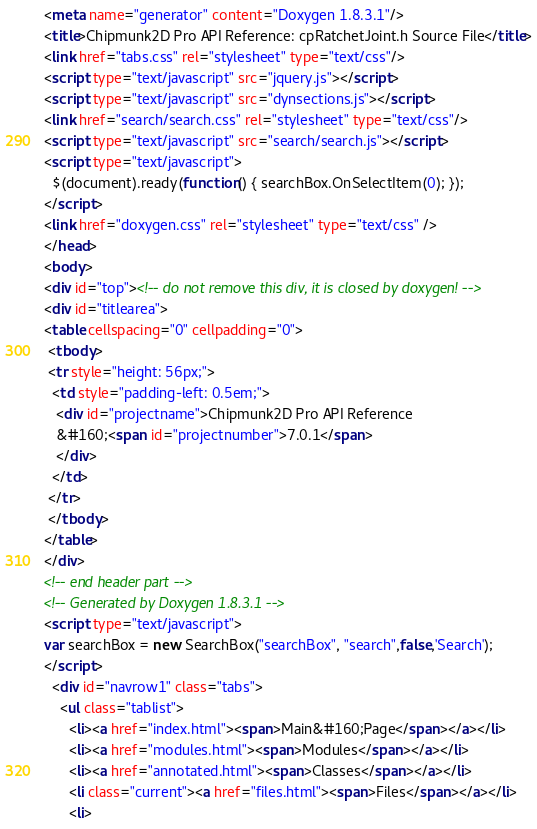<code> <loc_0><loc_0><loc_500><loc_500><_HTML_><meta name="generator" content="Doxygen 1.8.3.1"/>
<title>Chipmunk2D Pro API Reference: cpRatchetJoint.h Source File</title>
<link href="tabs.css" rel="stylesheet" type="text/css"/>
<script type="text/javascript" src="jquery.js"></script>
<script type="text/javascript" src="dynsections.js"></script>
<link href="search/search.css" rel="stylesheet" type="text/css"/>
<script type="text/javascript" src="search/search.js"></script>
<script type="text/javascript">
  $(document).ready(function() { searchBox.OnSelectItem(0); });
</script>
<link href="doxygen.css" rel="stylesheet" type="text/css" />
</head>
<body>
<div id="top"><!-- do not remove this div, it is closed by doxygen! -->
<div id="titlearea">
<table cellspacing="0" cellpadding="0">
 <tbody>
 <tr style="height: 56px;">
  <td style="padding-left: 0.5em;">
   <div id="projectname">Chipmunk2D Pro API Reference
   &#160;<span id="projectnumber">7.0.1</span>
   </div>
  </td>
 </tr>
 </tbody>
</table>
</div>
<!-- end header part -->
<!-- Generated by Doxygen 1.8.3.1 -->
<script type="text/javascript">
var searchBox = new SearchBox("searchBox", "search",false,'Search');
</script>
  <div id="navrow1" class="tabs">
    <ul class="tablist">
      <li><a href="index.html"><span>Main&#160;Page</span></a></li>
      <li><a href="modules.html"><span>Modules</span></a></li>
      <li><a href="annotated.html"><span>Classes</span></a></li>
      <li class="current"><a href="files.html"><span>Files</span></a></li>
      <li></code> 